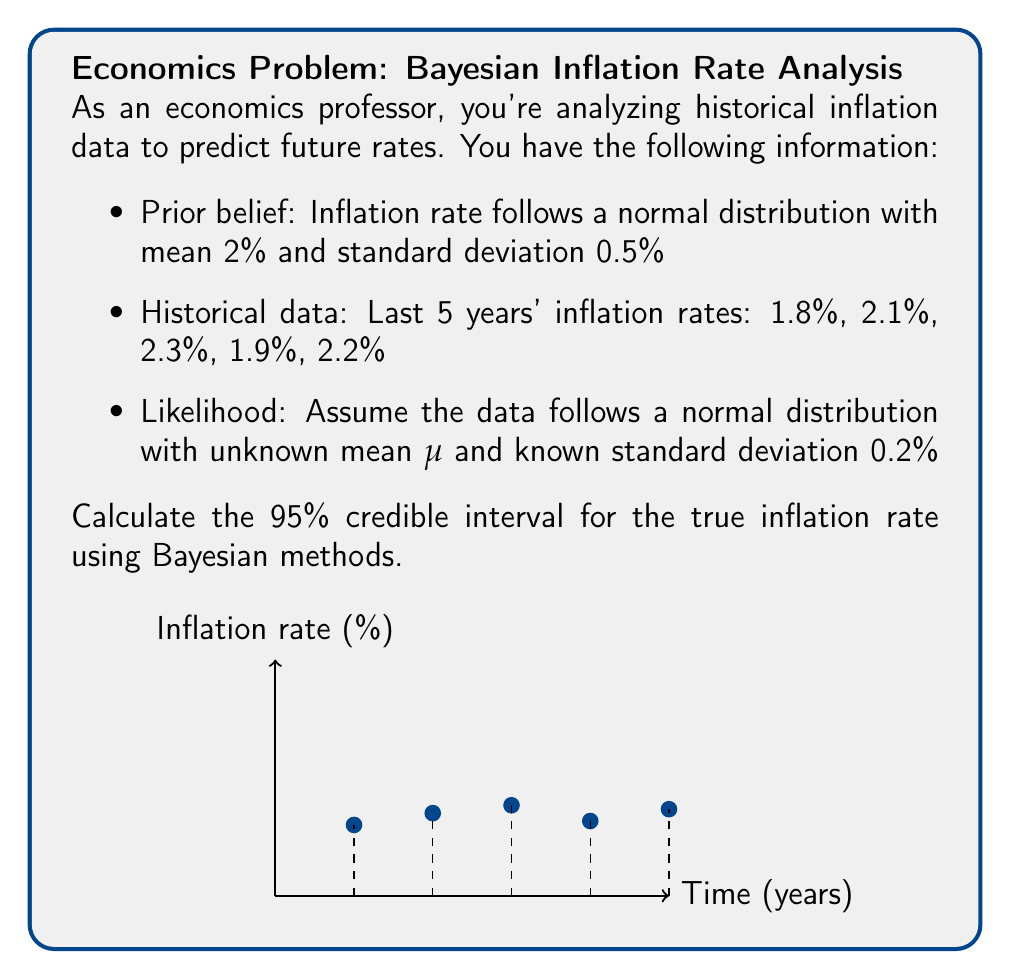Provide a solution to this math problem. Let's approach this step-by-step using Bayesian updating:

1) Prior distribution: $\mu_{prior} \sim N(2\%, 0.5\%^2)$

2) Likelihood: $x_i \sim N(\mu, 0.2\%^2)$

3) Calculate the sample mean:
   $$\bar{x} = \frac{1.8\% + 2.1\% + 2.3\% + 1.9\% + 2.2\%}{5} = 2.06\%$$

4) Bayesian updating formulas:
   $$\mu_{posterior} = \frac{\frac{\mu_{prior}}{\sigma_{prior}^2} + \frac{n\bar{x}}{\sigma_{likelihood}^2}}{\frac{1}{\sigma_{prior}^2} + \frac{n}{\sigma_{likelihood}^2}}$$
   
   $$\sigma_{posterior}^2 = \frac{1}{\frac{1}{\sigma_{prior}^2} + \frac{n}{\sigma_{likelihood}^2}}$$

5) Plug in the values:
   $$\mu_{posterior} = \frac{\frac{2\%}{0.5\%^2} + \frac{5 \cdot 2.06\%}{0.2\%^2}}{\frac{1}{0.5\%^2} + \frac{5}{0.2\%^2}} = 2.05\%$$
   
   $$\sigma_{posterior}^2 = \frac{1}{\frac{1}{0.5\%^2} + \frac{5}{0.2\%^2}} = 0.0289\%^2$$
   
   $$\sigma_{posterior} = 0.17\%$$

6) For a 95% credible interval, we use $\pm 1.96$ standard deviations:
   $$CI = \mu_{posterior} \pm 1.96 \cdot \sigma_{posterior}$$
   $$CI = 2.05\% \pm 1.96 \cdot 0.17\%$$
   $$CI = [1.72\%, 2.38\%]$$
Answer: [1.72%, 2.38%] 